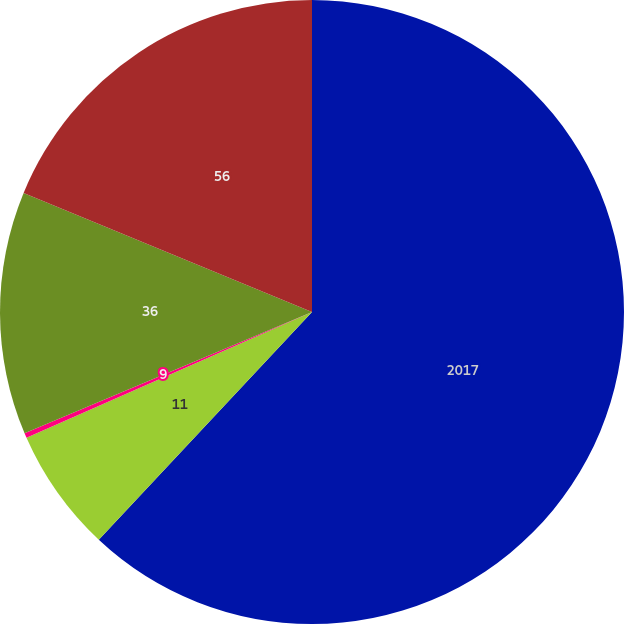Convert chart. <chart><loc_0><loc_0><loc_500><loc_500><pie_chart><fcel>2017<fcel>11<fcel>9<fcel>36<fcel>56<nl><fcel>61.98%<fcel>6.42%<fcel>0.25%<fcel>12.59%<fcel>18.77%<nl></chart> 